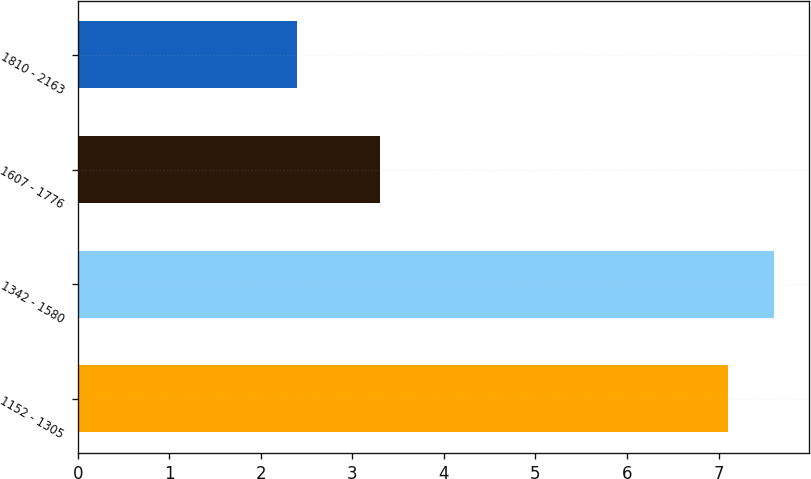Convert chart to OTSL. <chart><loc_0><loc_0><loc_500><loc_500><bar_chart><fcel>1152 - 1305<fcel>1342 - 1580<fcel>1607 - 1776<fcel>1810 - 2163<nl><fcel>7.1<fcel>7.61<fcel>3.3<fcel>2.4<nl></chart> 